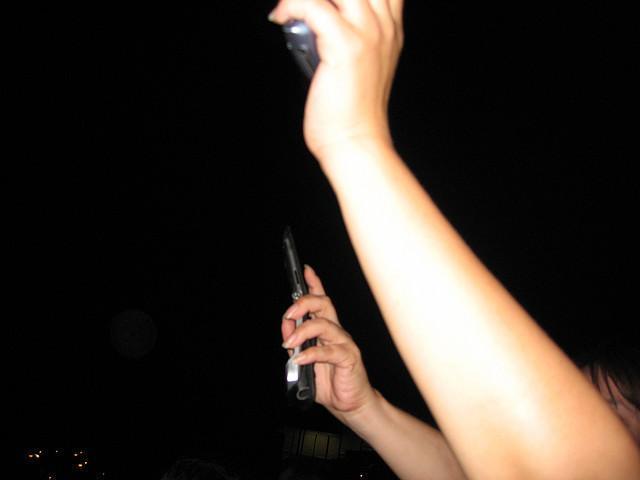How many cows are there?
Give a very brief answer. 0. 